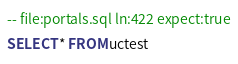Convert code to text. <code><loc_0><loc_0><loc_500><loc_500><_SQL_>-- file:portals.sql ln:422 expect:true
SELECT * FROM uctest
</code> 